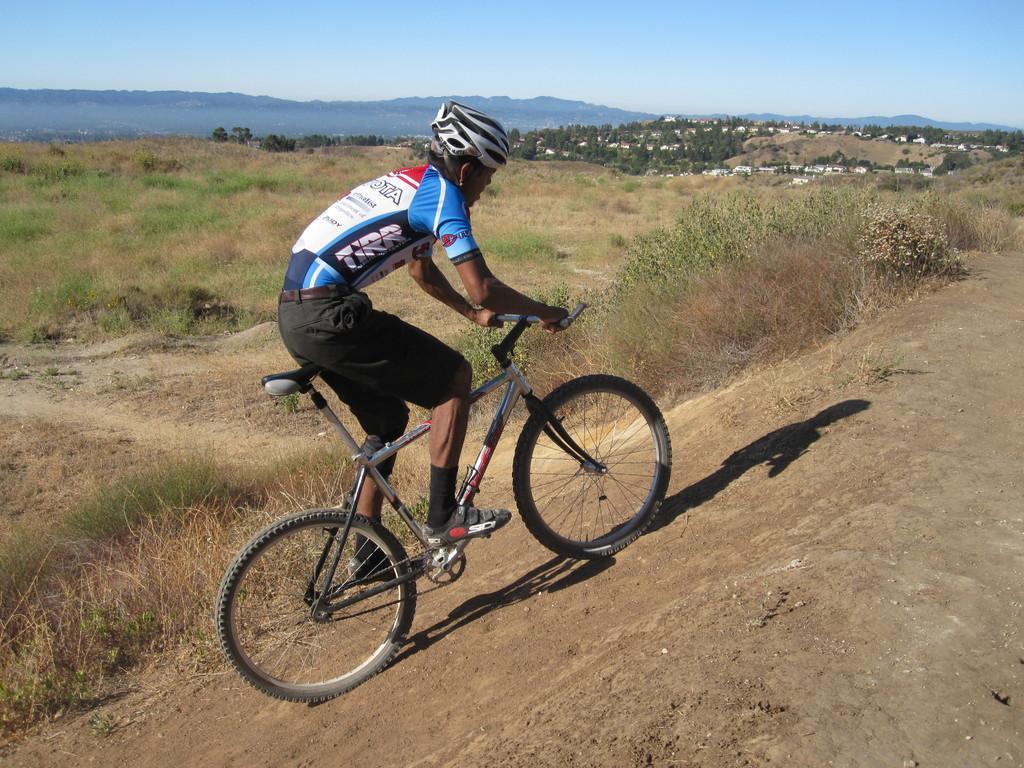Could you give a brief overview of what you see in this image? In this image, we can see some plants. There is a person in the middle of the image riding a bicycle. There is a sky at the top of the image. 